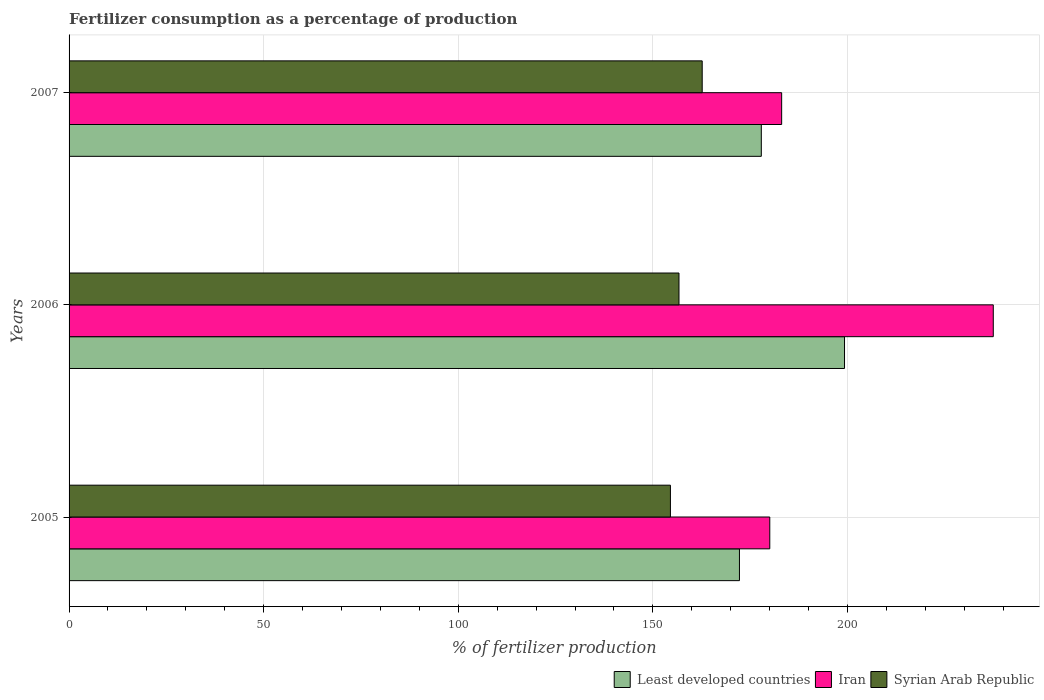Are the number of bars per tick equal to the number of legend labels?
Your answer should be compact. Yes. How many bars are there on the 3rd tick from the bottom?
Provide a succinct answer. 3. In how many cases, is the number of bars for a given year not equal to the number of legend labels?
Offer a terse response. 0. What is the percentage of fertilizers consumed in Syrian Arab Republic in 2006?
Offer a terse response. 156.72. Across all years, what is the maximum percentage of fertilizers consumed in Syrian Arab Republic?
Your response must be concise. 162.68. Across all years, what is the minimum percentage of fertilizers consumed in Iran?
Make the answer very short. 180.05. What is the total percentage of fertilizers consumed in Least developed countries in the graph?
Your answer should be compact. 549.38. What is the difference between the percentage of fertilizers consumed in Syrian Arab Republic in 2005 and that in 2006?
Make the answer very short. -2.2. What is the difference between the percentage of fertilizers consumed in Iran in 2005 and the percentage of fertilizers consumed in Syrian Arab Republic in 2007?
Your answer should be compact. 17.37. What is the average percentage of fertilizers consumed in Least developed countries per year?
Your response must be concise. 183.13. In the year 2005, what is the difference between the percentage of fertilizers consumed in Least developed countries and percentage of fertilizers consumed in Iran?
Provide a short and direct response. -7.79. In how many years, is the percentage of fertilizers consumed in Iran greater than 80 %?
Your response must be concise. 3. What is the ratio of the percentage of fertilizers consumed in Least developed countries in 2006 to that in 2007?
Provide a short and direct response. 1.12. Is the difference between the percentage of fertilizers consumed in Least developed countries in 2005 and 2007 greater than the difference between the percentage of fertilizers consumed in Iran in 2005 and 2007?
Your answer should be very brief. No. What is the difference between the highest and the second highest percentage of fertilizers consumed in Iran?
Provide a short and direct response. 54.38. What is the difference between the highest and the lowest percentage of fertilizers consumed in Iran?
Provide a succinct answer. 57.43. What does the 2nd bar from the top in 2007 represents?
Provide a short and direct response. Iran. What does the 1st bar from the bottom in 2007 represents?
Offer a terse response. Least developed countries. Is it the case that in every year, the sum of the percentage of fertilizers consumed in Iran and percentage of fertilizers consumed in Syrian Arab Republic is greater than the percentage of fertilizers consumed in Least developed countries?
Your answer should be compact. Yes. How many bars are there?
Keep it short and to the point. 9. Are all the bars in the graph horizontal?
Ensure brevity in your answer.  Yes. How many years are there in the graph?
Ensure brevity in your answer.  3. What is the difference between two consecutive major ticks on the X-axis?
Provide a succinct answer. 50. Where does the legend appear in the graph?
Provide a short and direct response. Bottom right. How are the legend labels stacked?
Offer a very short reply. Horizontal. What is the title of the graph?
Your answer should be compact. Fertilizer consumption as a percentage of production. What is the label or title of the X-axis?
Your answer should be very brief. % of fertilizer production. What is the % of fertilizer production of Least developed countries in 2005?
Ensure brevity in your answer.  172.25. What is the % of fertilizer production of Iran in 2005?
Your answer should be very brief. 180.05. What is the % of fertilizer production in Syrian Arab Republic in 2005?
Give a very brief answer. 154.52. What is the % of fertilizer production of Least developed countries in 2006?
Provide a succinct answer. 199.25. What is the % of fertilizer production in Iran in 2006?
Your answer should be compact. 237.47. What is the % of fertilizer production of Syrian Arab Republic in 2006?
Offer a very short reply. 156.72. What is the % of fertilizer production of Least developed countries in 2007?
Give a very brief answer. 177.87. What is the % of fertilizer production of Iran in 2007?
Keep it short and to the point. 183.1. What is the % of fertilizer production of Syrian Arab Republic in 2007?
Your answer should be compact. 162.68. Across all years, what is the maximum % of fertilizer production in Least developed countries?
Make the answer very short. 199.25. Across all years, what is the maximum % of fertilizer production of Iran?
Provide a short and direct response. 237.47. Across all years, what is the maximum % of fertilizer production in Syrian Arab Republic?
Offer a terse response. 162.68. Across all years, what is the minimum % of fertilizer production of Least developed countries?
Your answer should be compact. 172.25. Across all years, what is the minimum % of fertilizer production of Iran?
Your answer should be very brief. 180.05. Across all years, what is the minimum % of fertilizer production of Syrian Arab Republic?
Offer a very short reply. 154.52. What is the total % of fertilizer production of Least developed countries in the graph?
Offer a very short reply. 549.38. What is the total % of fertilizer production in Iran in the graph?
Offer a very short reply. 600.62. What is the total % of fertilizer production of Syrian Arab Republic in the graph?
Your answer should be very brief. 473.91. What is the difference between the % of fertilizer production in Least developed countries in 2005 and that in 2006?
Provide a succinct answer. -27. What is the difference between the % of fertilizer production of Iran in 2005 and that in 2006?
Keep it short and to the point. -57.43. What is the difference between the % of fertilizer production in Syrian Arab Republic in 2005 and that in 2006?
Provide a short and direct response. -2.2. What is the difference between the % of fertilizer production of Least developed countries in 2005 and that in 2007?
Provide a short and direct response. -5.62. What is the difference between the % of fertilizer production in Iran in 2005 and that in 2007?
Give a very brief answer. -3.05. What is the difference between the % of fertilizer production in Syrian Arab Republic in 2005 and that in 2007?
Your answer should be very brief. -8.17. What is the difference between the % of fertilizer production of Least developed countries in 2006 and that in 2007?
Give a very brief answer. 21.38. What is the difference between the % of fertilizer production in Iran in 2006 and that in 2007?
Your answer should be compact. 54.38. What is the difference between the % of fertilizer production in Syrian Arab Republic in 2006 and that in 2007?
Make the answer very short. -5.97. What is the difference between the % of fertilizer production in Least developed countries in 2005 and the % of fertilizer production in Iran in 2006?
Make the answer very short. -65.22. What is the difference between the % of fertilizer production in Least developed countries in 2005 and the % of fertilizer production in Syrian Arab Republic in 2006?
Offer a terse response. 15.54. What is the difference between the % of fertilizer production of Iran in 2005 and the % of fertilizer production of Syrian Arab Republic in 2006?
Provide a succinct answer. 23.33. What is the difference between the % of fertilizer production of Least developed countries in 2005 and the % of fertilizer production of Iran in 2007?
Offer a very short reply. -10.84. What is the difference between the % of fertilizer production of Least developed countries in 2005 and the % of fertilizer production of Syrian Arab Republic in 2007?
Offer a terse response. 9.57. What is the difference between the % of fertilizer production in Iran in 2005 and the % of fertilizer production in Syrian Arab Republic in 2007?
Your answer should be very brief. 17.37. What is the difference between the % of fertilizer production in Least developed countries in 2006 and the % of fertilizer production in Iran in 2007?
Make the answer very short. 16.15. What is the difference between the % of fertilizer production of Least developed countries in 2006 and the % of fertilizer production of Syrian Arab Republic in 2007?
Ensure brevity in your answer.  36.57. What is the difference between the % of fertilizer production in Iran in 2006 and the % of fertilizer production in Syrian Arab Republic in 2007?
Offer a very short reply. 74.79. What is the average % of fertilizer production in Least developed countries per year?
Your response must be concise. 183.13. What is the average % of fertilizer production in Iran per year?
Give a very brief answer. 200.21. What is the average % of fertilizer production in Syrian Arab Republic per year?
Offer a very short reply. 157.97. In the year 2005, what is the difference between the % of fertilizer production of Least developed countries and % of fertilizer production of Iran?
Your answer should be compact. -7.79. In the year 2005, what is the difference between the % of fertilizer production in Least developed countries and % of fertilizer production in Syrian Arab Republic?
Keep it short and to the point. 17.74. In the year 2005, what is the difference between the % of fertilizer production in Iran and % of fertilizer production in Syrian Arab Republic?
Make the answer very short. 25.53. In the year 2006, what is the difference between the % of fertilizer production of Least developed countries and % of fertilizer production of Iran?
Your answer should be very brief. -38.22. In the year 2006, what is the difference between the % of fertilizer production of Least developed countries and % of fertilizer production of Syrian Arab Republic?
Offer a very short reply. 42.53. In the year 2006, what is the difference between the % of fertilizer production of Iran and % of fertilizer production of Syrian Arab Republic?
Your answer should be compact. 80.76. In the year 2007, what is the difference between the % of fertilizer production in Least developed countries and % of fertilizer production in Iran?
Give a very brief answer. -5.22. In the year 2007, what is the difference between the % of fertilizer production of Least developed countries and % of fertilizer production of Syrian Arab Republic?
Your answer should be compact. 15.19. In the year 2007, what is the difference between the % of fertilizer production in Iran and % of fertilizer production in Syrian Arab Republic?
Your answer should be very brief. 20.41. What is the ratio of the % of fertilizer production of Least developed countries in 2005 to that in 2006?
Provide a succinct answer. 0.86. What is the ratio of the % of fertilizer production in Iran in 2005 to that in 2006?
Your answer should be very brief. 0.76. What is the ratio of the % of fertilizer production in Least developed countries in 2005 to that in 2007?
Offer a terse response. 0.97. What is the ratio of the % of fertilizer production in Iran in 2005 to that in 2007?
Provide a short and direct response. 0.98. What is the ratio of the % of fertilizer production of Syrian Arab Republic in 2005 to that in 2007?
Make the answer very short. 0.95. What is the ratio of the % of fertilizer production in Least developed countries in 2006 to that in 2007?
Keep it short and to the point. 1.12. What is the ratio of the % of fertilizer production in Iran in 2006 to that in 2007?
Provide a short and direct response. 1.3. What is the ratio of the % of fertilizer production in Syrian Arab Republic in 2006 to that in 2007?
Offer a terse response. 0.96. What is the difference between the highest and the second highest % of fertilizer production in Least developed countries?
Provide a succinct answer. 21.38. What is the difference between the highest and the second highest % of fertilizer production in Iran?
Offer a terse response. 54.38. What is the difference between the highest and the second highest % of fertilizer production in Syrian Arab Republic?
Give a very brief answer. 5.97. What is the difference between the highest and the lowest % of fertilizer production in Least developed countries?
Offer a terse response. 27. What is the difference between the highest and the lowest % of fertilizer production of Iran?
Provide a short and direct response. 57.43. What is the difference between the highest and the lowest % of fertilizer production of Syrian Arab Republic?
Offer a very short reply. 8.17. 